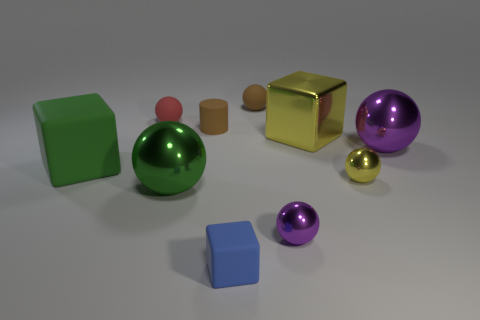Are the yellow cube and the tiny brown ball made of the same material?
Your response must be concise. No. Is there a tiny rubber block that is to the left of the small sphere to the left of the small object behind the red thing?
Offer a terse response. No. Are there fewer small blue shiny cylinders than yellow shiny things?
Your response must be concise. Yes. Is the material of the large ball that is behind the big green metallic object the same as the tiny cylinder that is to the right of the large rubber cube?
Give a very brief answer. No. Are there fewer big green things that are in front of the small blue thing than yellow metallic objects?
Offer a very short reply. Yes. There is a brown cylinder that is behind the big purple object; what number of brown cylinders are on the left side of it?
Offer a very short reply. 0. How big is the ball that is behind the yellow metal sphere and right of the small brown matte sphere?
Offer a very short reply. Large. Is the yellow cube made of the same material as the purple ball that is behind the tiny yellow thing?
Make the answer very short. Yes. Is the number of small matte cylinders in front of the small blue matte thing less than the number of green spheres that are right of the large purple object?
Keep it short and to the point. No. What material is the purple object behind the tiny purple sphere?
Make the answer very short. Metal. 